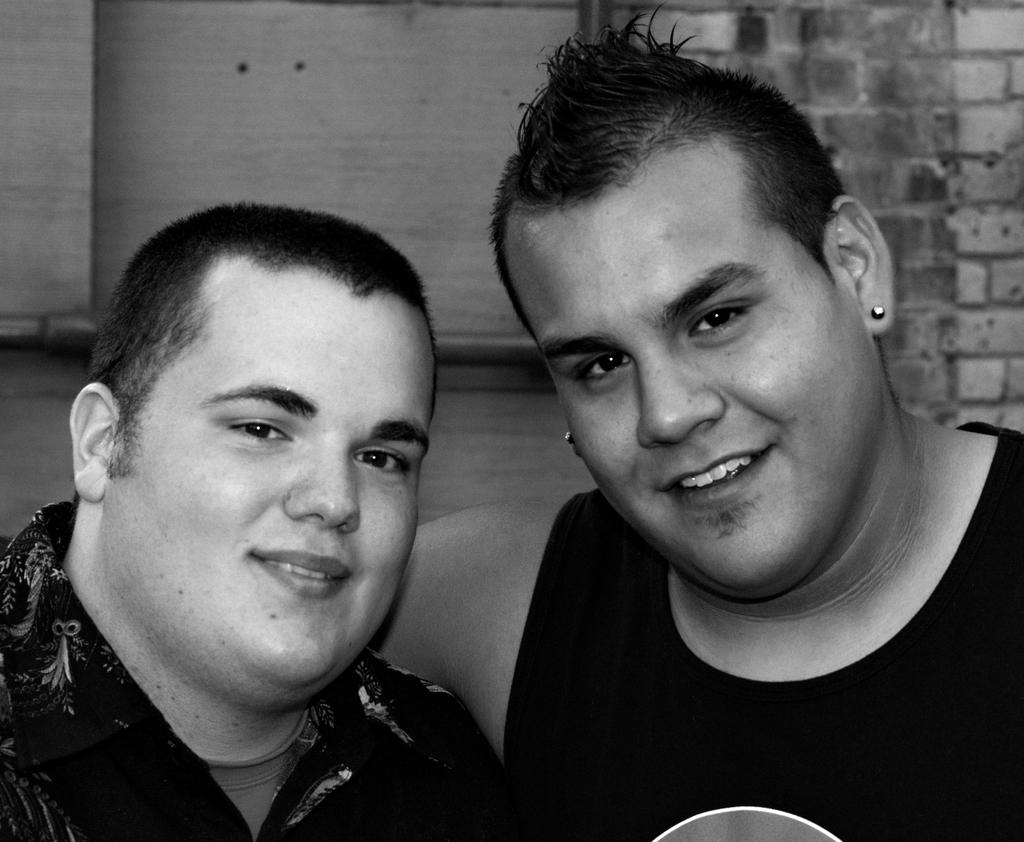What is the color scheme of the image? The image is black and white. Who or what can be seen in the image? There are men in the image. What can be seen in the background of the image? There are walls in the background of the image. What type of farm animals can be seen in the image? There are no farm animals present in the image; it features men and walls in a black and white setting. How many times does the man roll the spade in the image? There is no spade present in the image, so it is not possible to determine how many times it might be rolled. 